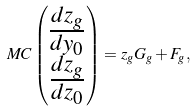<formula> <loc_0><loc_0><loc_500><loc_500>M C \begin{pmatrix} \frac { d z _ { g } } { d y _ { 0 } } \\ \frac { d z _ { g } } { d z _ { 0 } } \end{pmatrix} = z _ { g } G _ { g } + F _ { g } ,</formula> 